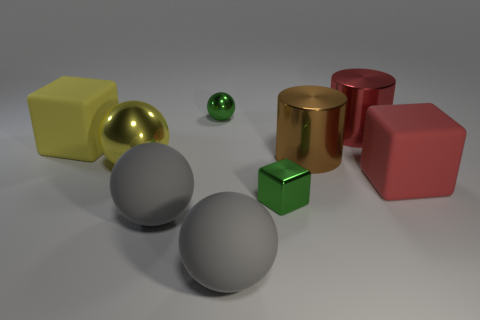What number of metallic things are either red cubes or small objects?
Make the answer very short. 2. There is a yellow thing behind the big yellow sphere; is it the same shape as the brown metal thing?
Your response must be concise. No. Are there more large brown metallic cylinders behind the brown cylinder than red objects?
Provide a succinct answer. No. How many things are both right of the big brown thing and in front of the green block?
Provide a succinct answer. 0. What is the color of the sphere behind the large yellow metallic sphere that is behind the small green block?
Offer a terse response. Green. What number of cylinders have the same color as the tiny metallic cube?
Your response must be concise. 0. Do the tiny metallic block and the large matte block that is in front of the big yellow matte block have the same color?
Make the answer very short. No. Is the number of green metallic objects less than the number of green balls?
Offer a terse response. No. Is the number of large matte cubes on the right side of the green shiny sphere greater than the number of red blocks that are to the right of the red block?
Your answer should be compact. Yes. Does the big brown thing have the same material as the red cylinder?
Offer a terse response. Yes. 